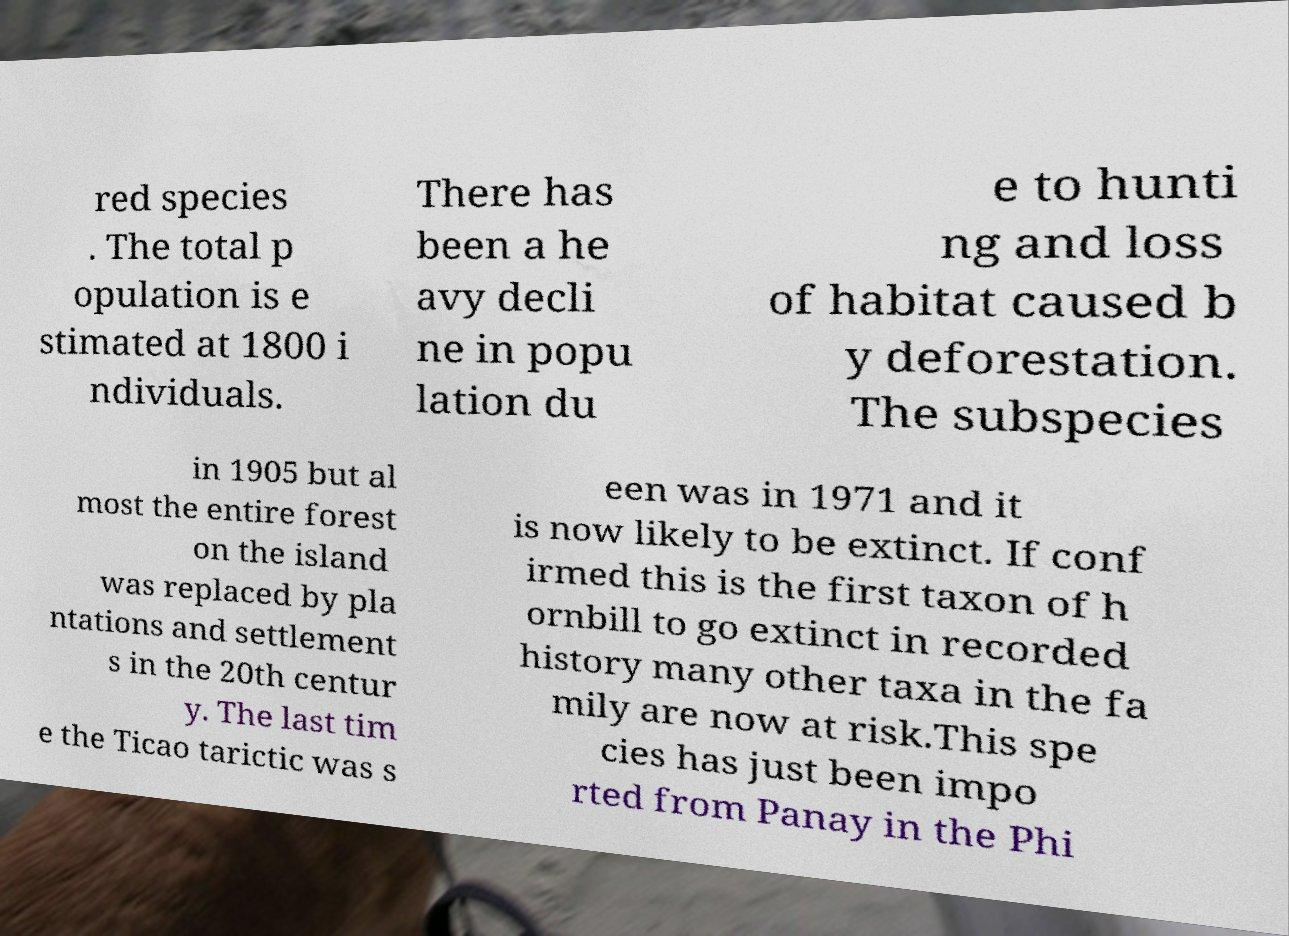Could you extract and type out the text from this image? red species . The total p opulation is e stimated at 1800 i ndividuals. There has been a he avy decli ne in popu lation du e to hunti ng and loss of habitat caused b y deforestation. The subspecies in 1905 but al most the entire forest on the island was replaced by pla ntations and settlement s in the 20th centur y. The last tim e the Ticao tarictic was s een was in 1971 and it is now likely to be extinct. If conf irmed this is the first taxon of h ornbill to go extinct in recorded history many other taxa in the fa mily are now at risk.This spe cies has just been impo rted from Panay in the Phi 